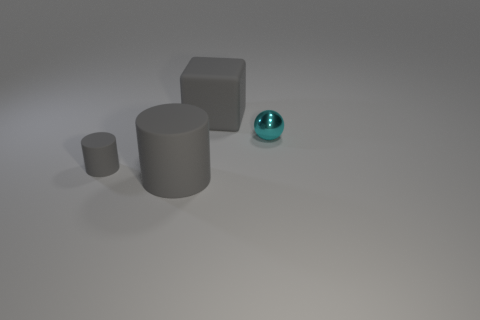Add 1 small balls. How many objects exist? 5 Subtract all balls. How many objects are left? 3 Add 1 spheres. How many spheres are left? 2 Add 3 large gray cubes. How many large gray cubes exist? 4 Subtract 0 brown spheres. How many objects are left? 4 Subtract all tiny gray objects. Subtract all large cylinders. How many objects are left? 2 